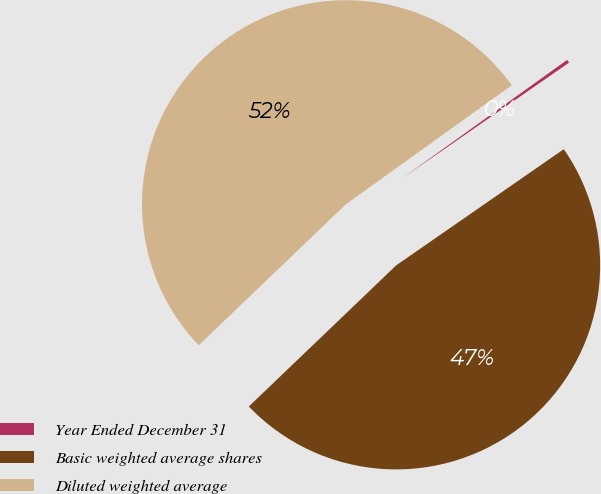Convert chart. <chart><loc_0><loc_0><loc_500><loc_500><pie_chart><fcel>Year Ended December 31<fcel>Basic weighted average shares<fcel>Diluted weighted average<nl><fcel>0.26%<fcel>47.49%<fcel>52.25%<nl></chart> 